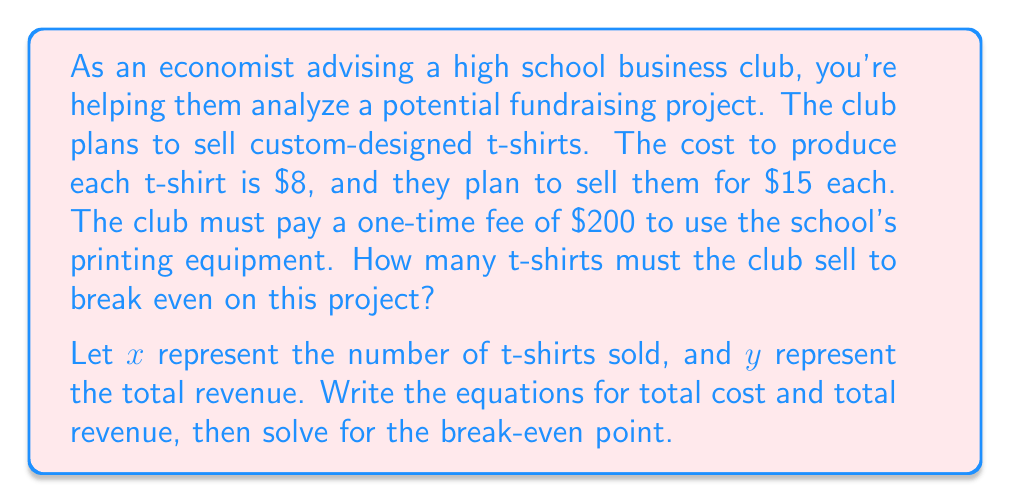Could you help me with this problem? To solve this problem, we need to use linear equations to find the break-even point. Let's approach this step-by-step:

1. Define the variables:
   $x$ = number of t-shirts sold
   $y$ = total revenue or total cost

2. Write the equation for total revenue:
   Revenue per t-shirt = $15
   Total Revenue: $y = 15x$

3. Write the equation for total cost:
   Fixed cost = $200
   Variable cost per t-shirt = $8
   Total Cost: $y = 200 + 8x$

4. At the break-even point, total revenue equals total cost:
   $15x = 200 + 8x$

5. Solve the equation:
   $15x - 8x = 200$
   $7x = 200$
   $x = \frac{200}{7} \approx 28.57$

6. Since we can't sell a fraction of a t-shirt, we round up to the nearest whole number.

The break-even point occurs when the club sells 29 t-shirts.

To verify:
Revenue: $29 \times $15 = $435
Cost: $200 + (29 \times $8) = $432

At 29 t-shirts, revenue slightly exceeds costs, confirming the break-even point.
Answer: The club must sell 29 t-shirts to break even on this project. 